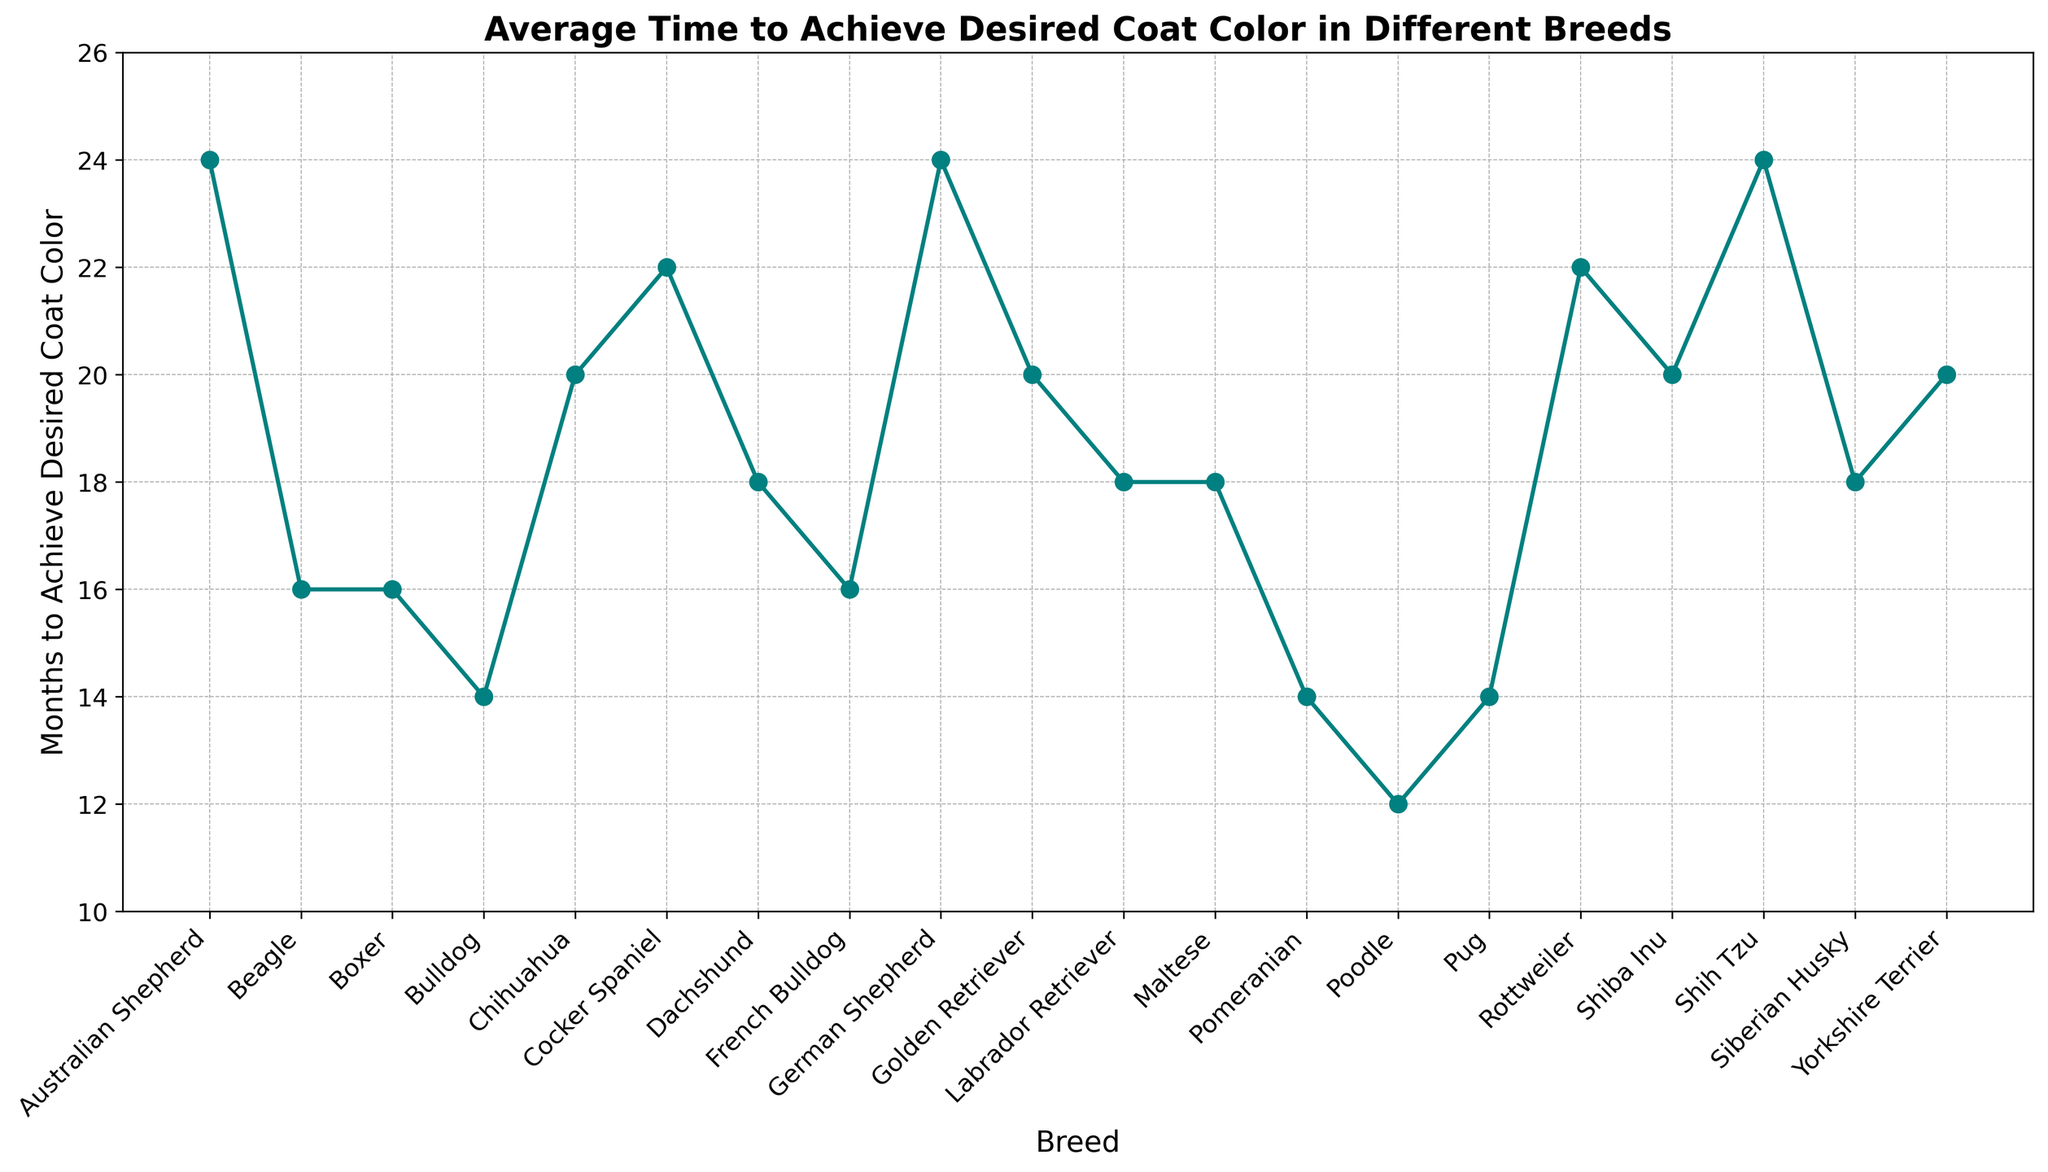What breed takes the longest time to achieve the desired coat color? By looking at the highest point on the y-axis, Shih Tzu, German Shepherd, and Australian Shepherd all take 24 months to achieve the desired coat color.
Answer: Shih Tzu, German Shepherd, Australian Shepherd Which breed achieves the desired coat color the fastest? By identifying the lowest point on the y-axis, Poodle, Bulldog, Pomeranian, and Pug all take 14 months to achieve the desired coat color.
Answer: Poodle, Bulldog, Pomeranian, Pug What is the average time to achieve the desired coat color across all breeds? Sum up the months to achieve the desired coat color for all breeds and divide by the number of breeds. Total sum = 366, Number of breeds = 20, Average = 366 / 20 = 18.3
Answer: 18.3 months Which breeds have a time to achieve the desired coat color that is greater than the average time? By comparing each breed's months to the average time (18.3 months), the breeds that take longer are German Shepherd (24), Shih Tzu (24), Cocker Spaniel (22), Rottweiler (22), Golden Retriever (20), Chihuahua (20), Yorkshire Terrier (20), and Shiba Inu (20)
Answer: German Shepherd, Shih Tzu, Cocker Spaniel, Rottweiler, Golden Retriever, Chihuahua, Yorkshire Terrier, Shiba Inu What is the difference between the breed that takes the longest and the shortest time to achieve the desired coat color? The longest time is 24 months, and the shortest time is 14 months. The difference is 24 - 14 = 10 months
Answer: 10 months How many breeds take exactly 18 months to achieve the desired coat color? Look at the data points where the y-value is 18. The breeds are Labrador Retriever, Siberian Husky, Dachshund, and Maltese. There are 4 such breeds.
Answer: 4 breeds What is the median value of months to achieve the desired coat color? The data has 20 values. When sorted, the middle values (10th and 11th) are both 18. Therefore, the median is (18 + 18) / 2 = 18
Answer: 18 months Are there any breeds that take more than 20 months but fewer than 24 months to achieve the desired coat color? The breeds that fall in this range are Cocker Spaniel and Rottweiler, which both take 22 months.
Answer: Cocker Spaniel, Rottweiler 